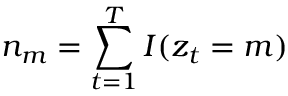<formula> <loc_0><loc_0><loc_500><loc_500>n _ { m } = \sum _ { t = 1 } ^ { T } I ( z _ { t } = m )</formula> 